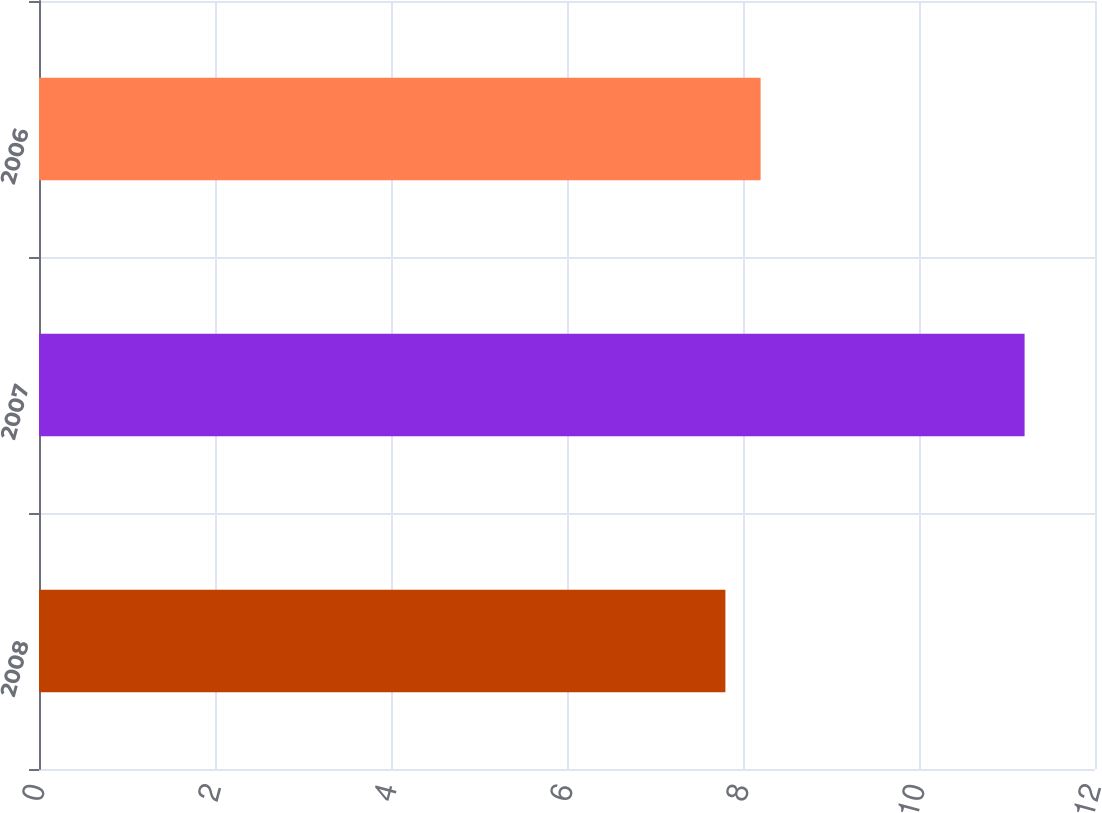Convert chart. <chart><loc_0><loc_0><loc_500><loc_500><bar_chart><fcel>2008<fcel>2007<fcel>2006<nl><fcel>7.8<fcel>11.2<fcel>8.2<nl></chart> 